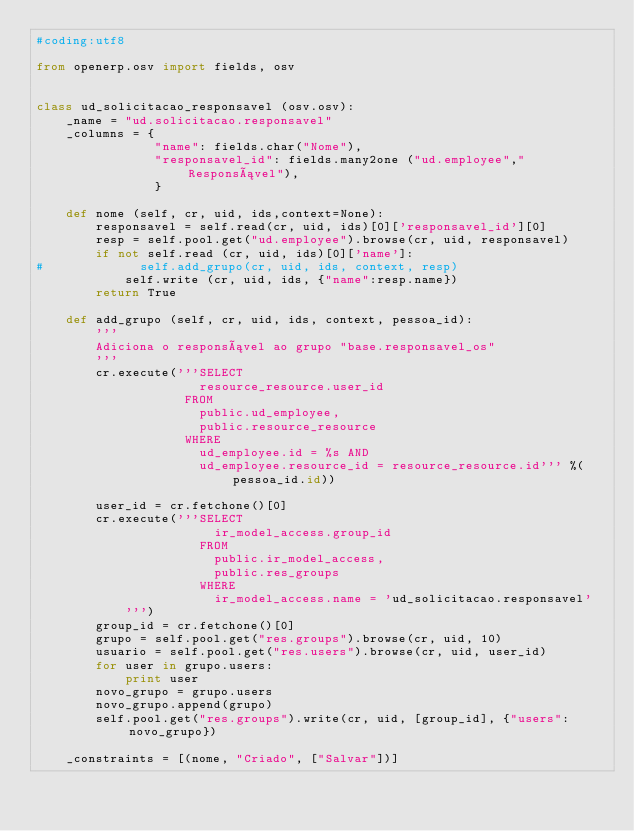<code> <loc_0><loc_0><loc_500><loc_500><_Python_>#coding:utf8

from openerp.osv import fields, osv


class ud_solicitacao_responsavel (osv.osv):
    _name = "ud.solicitacao.responsavel"
    _columns = {
                "name": fields.char("Nome"),
                "responsavel_id": fields.many2one ("ud.employee","Responsável"),                                
                }
    
    def nome (self, cr, uid, ids,context=None):
        responsavel = self.read(cr, uid, ids)[0]['responsavel_id'][0]
        resp = self.pool.get("ud.employee").browse(cr, uid, responsavel)
        if not self.read (cr, uid, ids)[0]['name']:
#             self.add_grupo(cr, uid, ids, context, resp)
            self.write (cr, uid, ids, {"name":resp.name})
        return True
    
    def add_grupo (self, cr, uid, ids, context, pessoa_id):
        '''
        Adiciona o responsável ao grupo "base.responsavel_os"
        '''
        cr.execute('''SELECT 
                      resource_resource.user_id
                    FROM 
                      public.ud_employee, 
                      public.resource_resource
                    WHERE 
                      ud_employee.id = %s AND
                      ud_employee.resource_id = resource_resource.id''' %(pessoa_id.id))

        user_id = cr.fetchone()[0]
        cr.execute('''SELECT
                        ir_model_access.group_id
                      FROM
                        public.ir_model_access,
                        public.res_groups
                      WHERE
                        ir_model_access.name = 'ud_solicitacao.responsavel'
            ''')
        group_id = cr.fetchone()[0]
        grupo = self.pool.get("res.groups").browse(cr, uid, 10)
        usuario = self.pool.get("res.users").browse(cr, uid, user_id)
        for user in grupo.users:
            print user
        novo_grupo = grupo.users
        novo_grupo.append(grupo)
        self.pool.get("res.groups").write(cr, uid, [group_id], {"users":novo_grupo})

    _constraints = [(nome, "Criado", ["Salvar"])]
    </code> 